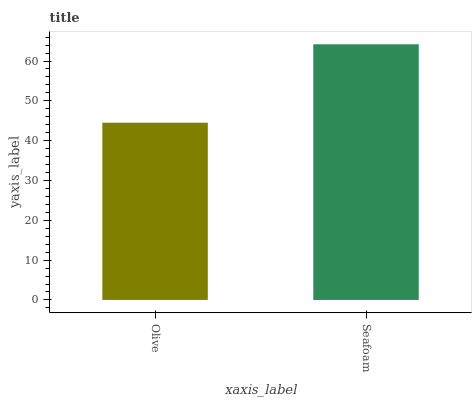Is Olive the minimum?
Answer yes or no. Yes. Is Seafoam the maximum?
Answer yes or no. Yes. Is Seafoam the minimum?
Answer yes or no. No. Is Seafoam greater than Olive?
Answer yes or no. Yes. Is Olive less than Seafoam?
Answer yes or no. Yes. Is Olive greater than Seafoam?
Answer yes or no. No. Is Seafoam less than Olive?
Answer yes or no. No. Is Seafoam the high median?
Answer yes or no. Yes. Is Olive the low median?
Answer yes or no. Yes. Is Olive the high median?
Answer yes or no. No. Is Seafoam the low median?
Answer yes or no. No. 